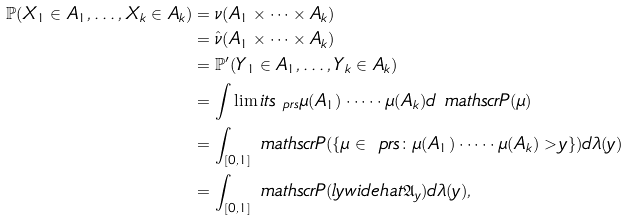Convert formula to latex. <formula><loc_0><loc_0><loc_500><loc_500>\mathbb { P } ( X _ { 1 } \in A _ { 1 } , \dots , X _ { k } \in A _ { k } ) & = \nu ( A _ { 1 } \times \dots \times A _ { k } ) \\ & = \hat { \nu } ( A _ { 1 } \times \dots \times A _ { k } ) \\ & = \mathbb { P } ^ { \prime } ( Y _ { 1 } \in A _ { 1 } , \dots , Y _ { k } \in A _ { k } ) \\ & = \int \lim i t s _ { \ p r s } \mu ( A _ { 1 } ) \cdot \dots \cdot \mu ( A _ { k } ) d \ m a t h s c r { P } ( \mu ) \\ & = \int _ { [ 0 , 1 ] } \ m a t h s c r { P } ( \{ \mu \in \ p r s \colon \mu ( A _ { 1 } ) \cdot \dots \cdot \mu ( A _ { k } ) > y \} ) d \lambda ( y ) \\ & = \int _ { [ 0 , 1 ] } \ m a t h s c r { P } ( \real l y w i d e h a t { \mathfrak { A } _ { y } } ) d \lambda ( y ) ,</formula> 